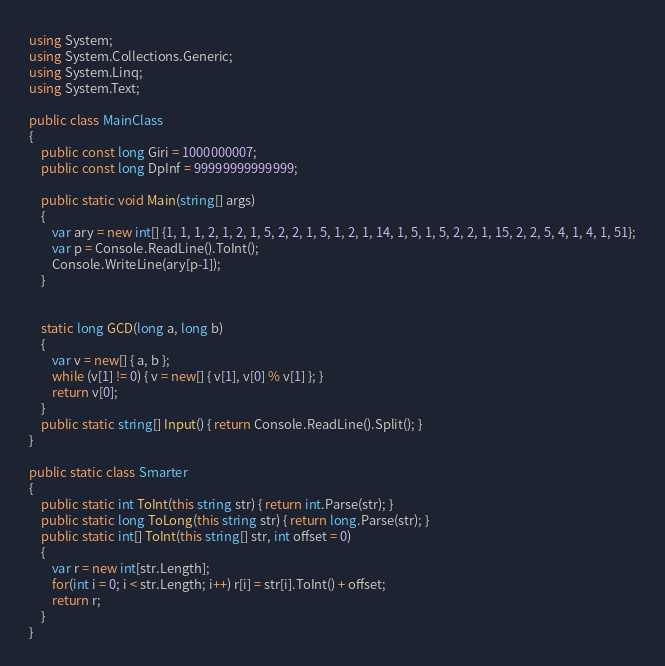<code> <loc_0><loc_0><loc_500><loc_500><_C#_>using System;
using System.Collections.Generic;
using System.Linq;
using System.Text;

public class MainClass
{
	public const long Giri = 1000000007;
	public const long DpInf = 99999999999999;
	
	public static void Main(string[] args)
	{
		var ary = new int[] {1, 1, 1, 2, 1, 2, 1, 5, 2, 2, 1, 5, 1, 2, 1, 14, 1, 5, 1, 5, 2, 2, 1, 15, 2, 2, 5, 4, 1, 4, 1, 51};
		var p = Console.ReadLine().ToInt();
		Console.WriteLine(ary[p-1]);
	}
	

	static long GCD(long a, long b)
	{
		var v = new[] { a, b };
		while (v[1] != 0) { v = new[] { v[1], v[0] % v[1] }; }
		return v[0];
	}
	public static string[] Input() { return Console.ReadLine().Split(); }
}

public static class Smarter
{
	public static int ToInt(this string str) { return int.Parse(str); }
	public static long ToLong(this string str) { return long.Parse(str); }
	public static int[] ToInt(this string[] str, int offset = 0)
	{
		var r = new int[str.Length];
		for(int i = 0; i < str.Length; i++) r[i] = str[i].ToInt() + offset;
		return r;
	}
}</code> 